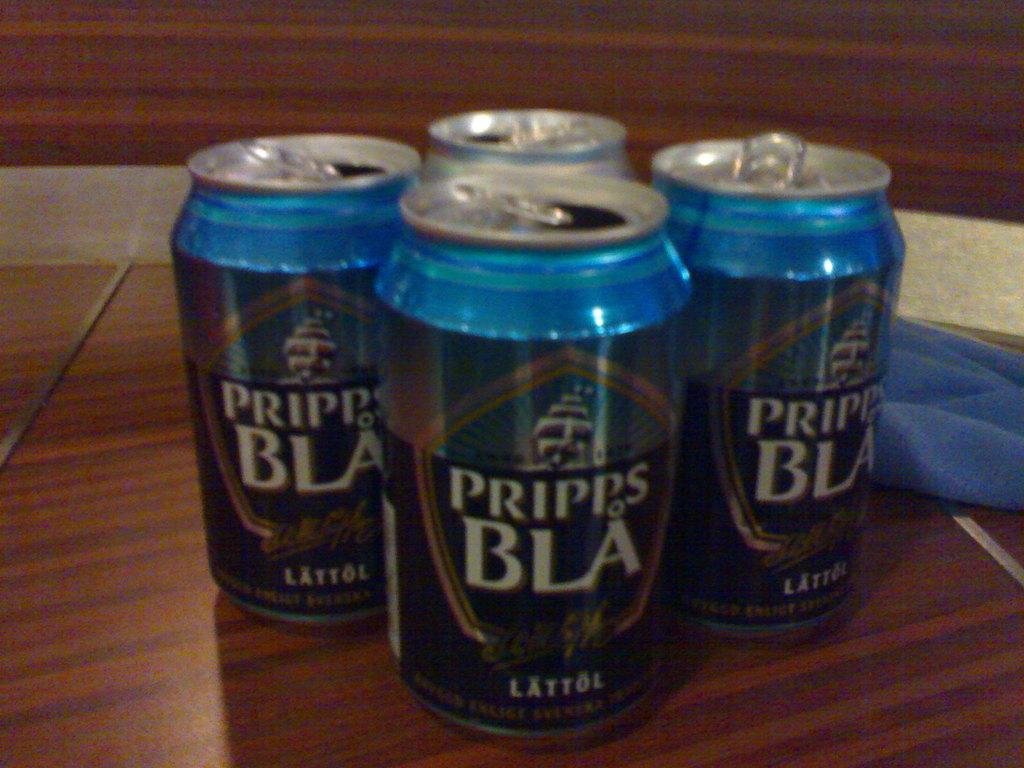<image>
Provide a brief description of the given image. Four cans of brand name Pripes BLA LATTOL on the front of the cans. 